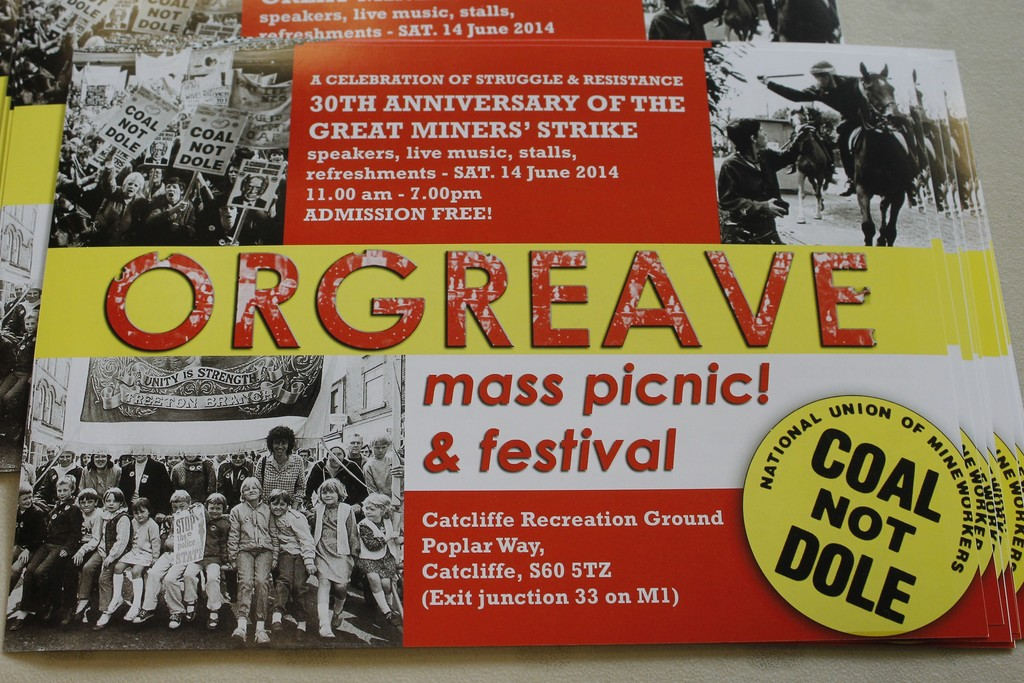Can you tell me more about the historical significance of the miners' strike mentioned on the poster? The miners' strike of 1984-85 was a major industrial action in the UK's history, where miners protested against the closure of coal mines by the government, which they saw as a threat to their jobs and communities. It was marked by passionate picketing and clashes with the police, symbolizing a broader struggle for workers' rights and social justice. The event on the poster commemorates this pivotal moment, honoring the courage and unity of the miners. 